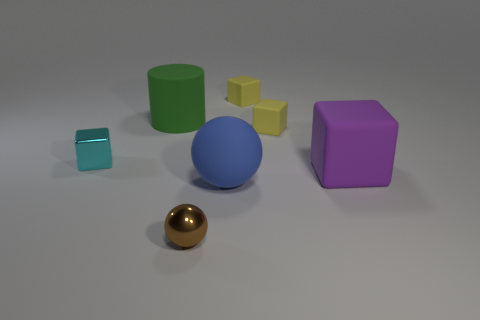The purple matte thing that is the same shape as the cyan metal thing is what size?
Make the answer very short. Large. There is a big matte object that is the same shape as the tiny cyan metal object; what is its color?
Provide a short and direct response. Purple. What is the small thing that is in front of the big purple cube made of?
Keep it short and to the point. Metal. What is the color of the large rubber cube?
Make the answer very short. Purple. Is the size of the ball that is behind the brown metal thing the same as the large cube?
Keep it short and to the point. Yes. What is the material of the tiny thing that is in front of the small shiny thing on the left side of the small thing that is in front of the big cube?
Provide a succinct answer. Metal. There is a tiny rubber object behind the big cylinder; is it the same color as the tiny rubber block that is in front of the large rubber cylinder?
Offer a very short reply. Yes. The tiny block that is to the left of the metal thing that is in front of the big cube is made of what material?
Provide a succinct answer. Metal. There is a shiny object that is the same size as the metal cube; what color is it?
Keep it short and to the point. Brown. Do the purple object and the shiny thing that is behind the matte ball have the same shape?
Your response must be concise. Yes. 